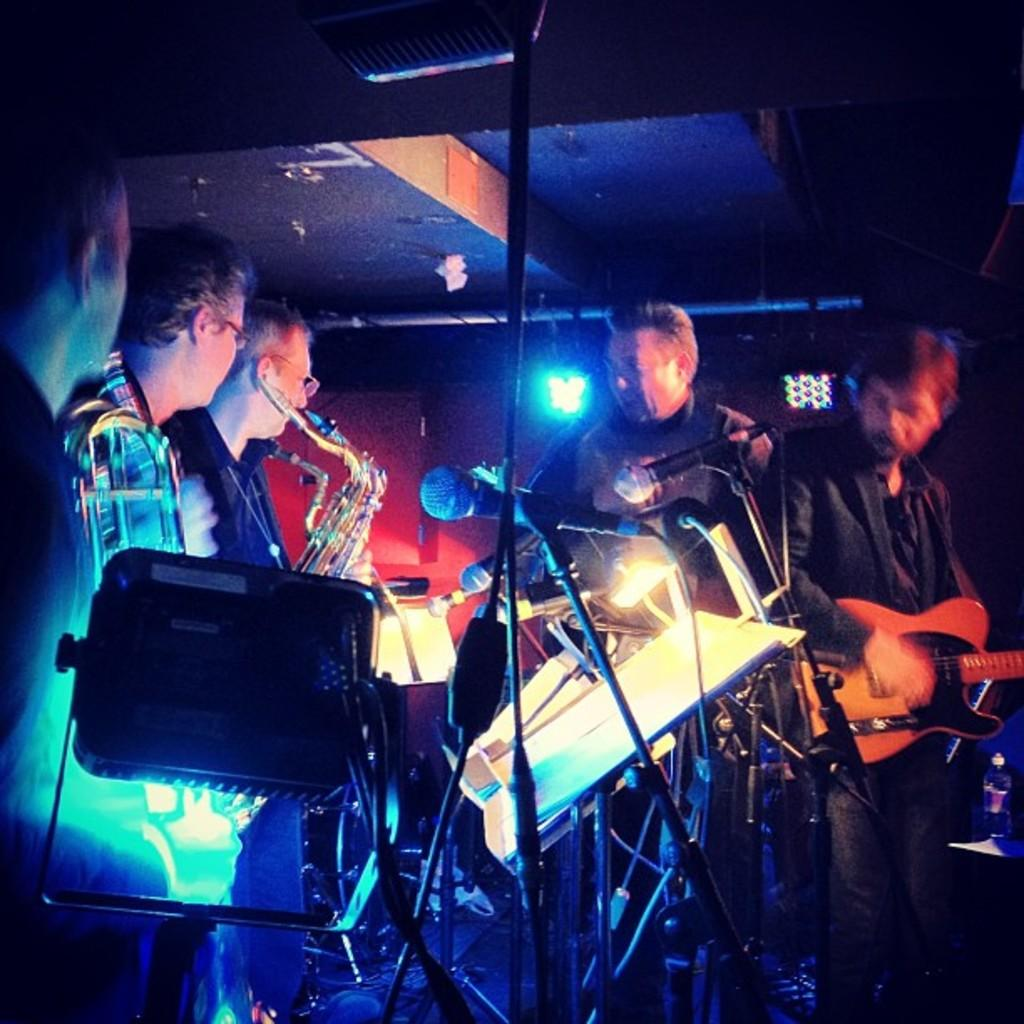What are the persons in the image doing? The persons in the image are playing a musical instrument. What is in front of the persons? There is a microphone in front of the persons. What can be seen in the image that might be used for illumination? There is a focusing light in the image. What is on the board in the image? There are papers on the board in the image. How many birds are perched on the microphone in the image? There are no birds present in the image, so it is not possible to determine the number of birds on the microphone. 